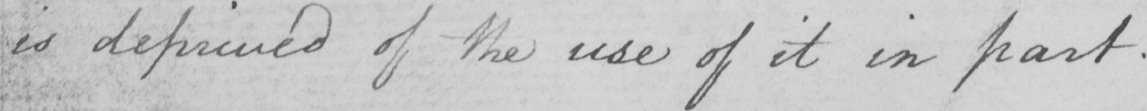Can you tell me what this handwritten text says? is deprived of the use of it in part. 